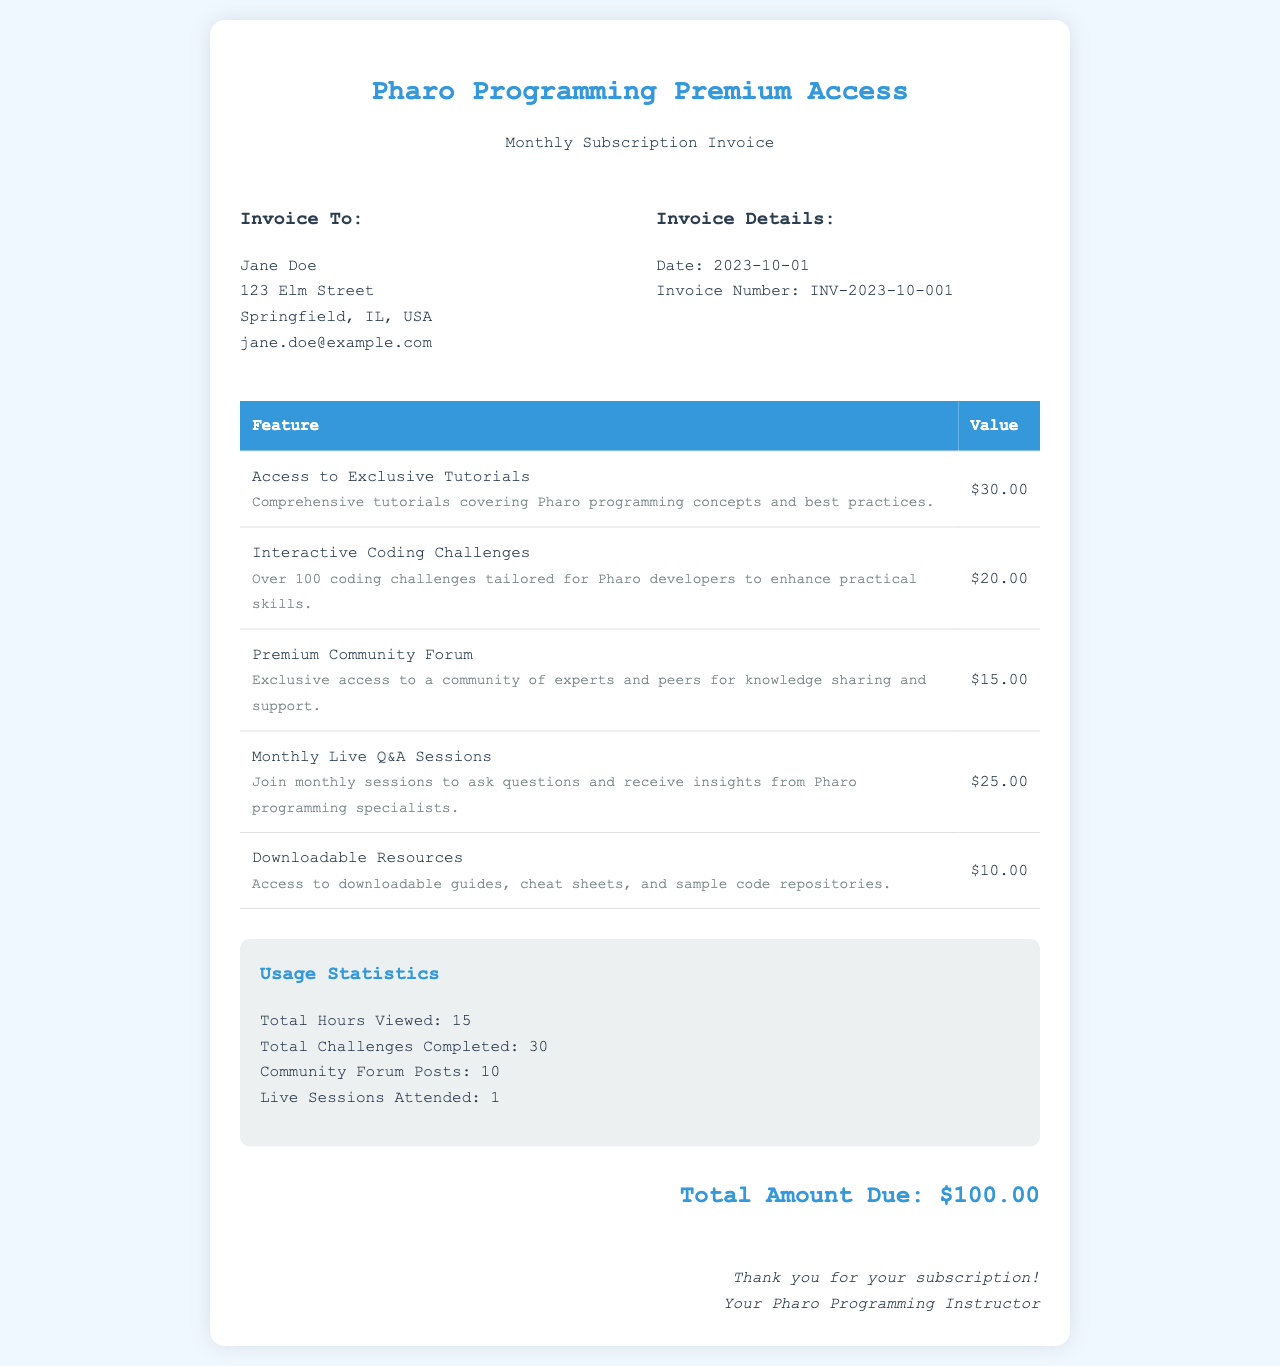What is the total amount due? The total amount due is found in the total amount section of the invoice, which lists the final cost.
Answer: $100.00 Who is the invoice addressed to? The invoice recipient is listed under "Invoice To," providing the name of the person receiving the invoice.
Answer: Jane Doe What date was the invoice issued? The invoice date is mentioned in the invoice details section, indicating when the invoice was created.
Answer: 2023-10-01 How many total challenges were completed? The total challenges completed are provided in the usage statistics section of the invoice.
Answer: 30 What feature provides access to community knowledge sharing? The feature involving community interaction is listed as part of the provided services, highlighting community access.
Answer: Premium Community Forum Which feature costs the least? The feature pricing is detailed in the table, allowing for comparison of costs to determine the least expensive option.
Answer: Downloadable Resources How many live Q&A sessions did the customer attend? The information about live session attendance is found under usage statistics, detailing participation in such events.
Answer: 1 What is the invoice number? The invoice number is stated in the invoice details, serving as a unique identifier for this particular invoice.
Answer: INV-2023-10-001 What is the feature that provides comprehensive tutorials? The feature focusing on tutorials is described in the table, specifically mentioning its educational content.
Answer: Access to Exclusive Tutorials 